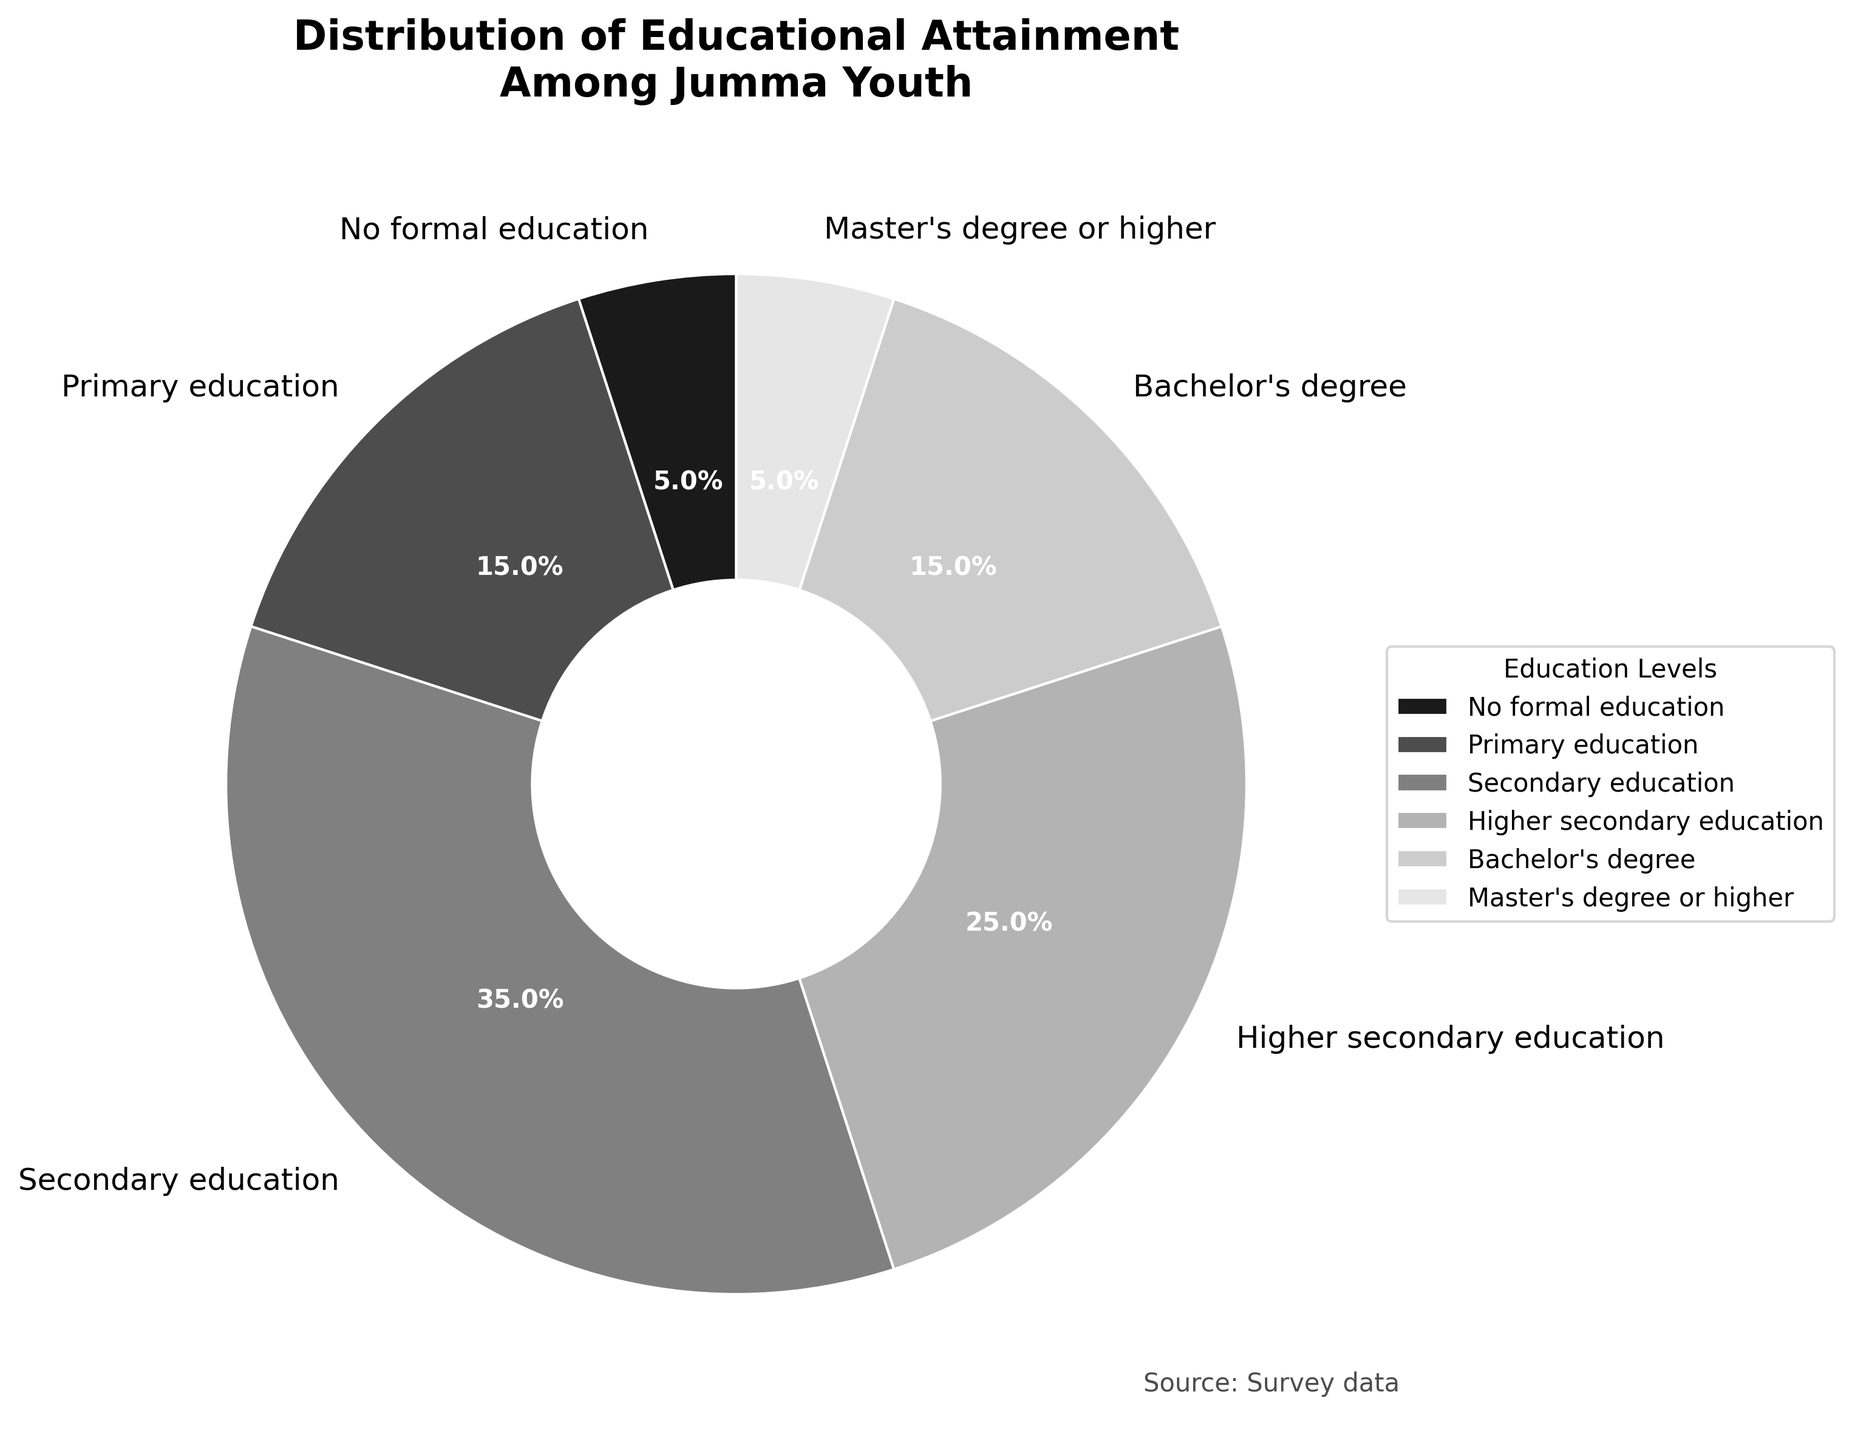What's the largest percentage of education level among Jumma youth? To find the largest percentage, look at the figures in the pie chart. The largest segment is the one labeled "Secondary education" with 35%.
Answer: 35% What's the combined percentage of Jumma youth with a Bachelor's degree and Master's degree or higher? Add the percentages of Bachelor's degree (15%) and Master's degree or higher (5%). So, 15% + 5% = 20%.
Answer: 20% Which education level has the smallest percentage among Jumma youth? Look at the smallest slice in the pie chart, which corresponds to "No formal education" and "Master's degree or higher," each with 5%.
Answer: No formal education and Master's degree or higher Is the percentage of Jumma youth with Secondary education greater than the combined percentage for No formal education and Primary education? Compare the percentages directly. Secondary education has 35%. No formal education and Primary education combined gives 5% + 15% = 20%. 35% is greater than 20%.
Answer: Yes What's the difference in percentage between Jumma youth with Secondary education and those with Higher secondary education? Subtract the Higher secondary education percentage (25%) from the Secondary education percentage (35%). So, 35% - 25% = 10%.
Answer: 10% What's the percentage of Jumma youth who do not have any form of higher education (Bachelor's degree or higher)? Sum the percentages of No formal education, Primary education, Secondary education, and Higher secondary education. That is, 5% + 15% + 35% + 25% = 80%.
Answer: 80% Which education level has a percentage equal to the sum of No formal education and Bachelor's degree percentages? The percentage of No formal education is 5% and Bachelor's degree is 15%. Their sum is 5% + 15% = 20%. The level that matches this is "Primary education" with 15%.
Answer: Primary education 